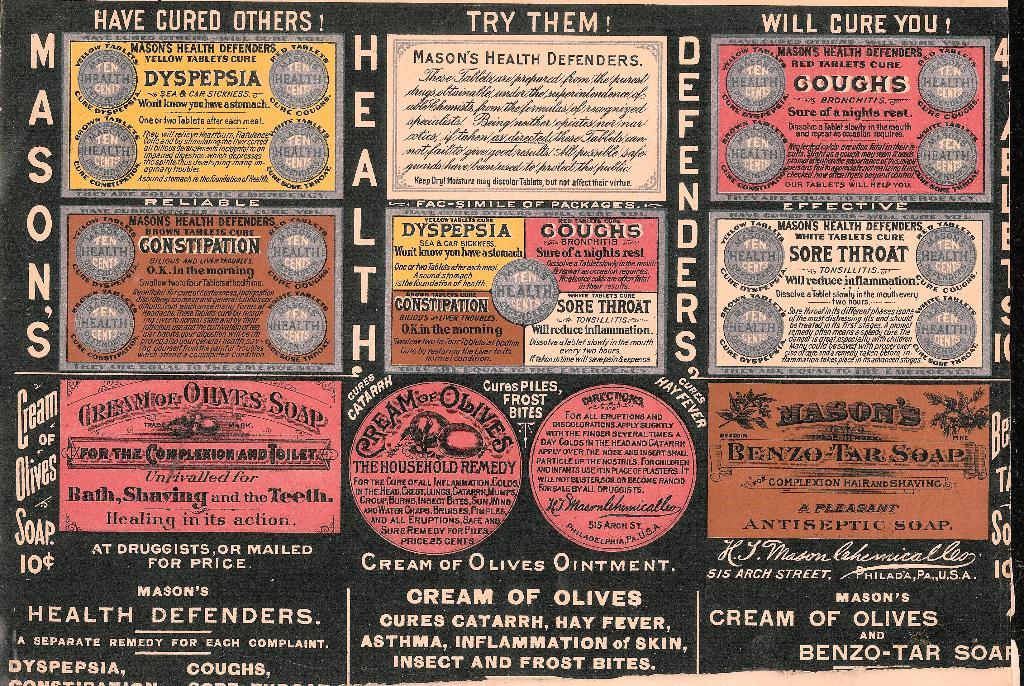How much does the soap cost?
Keep it short and to the point. 10 cents. What is the brand of soap?
Ensure brevity in your answer.  Mason's. 